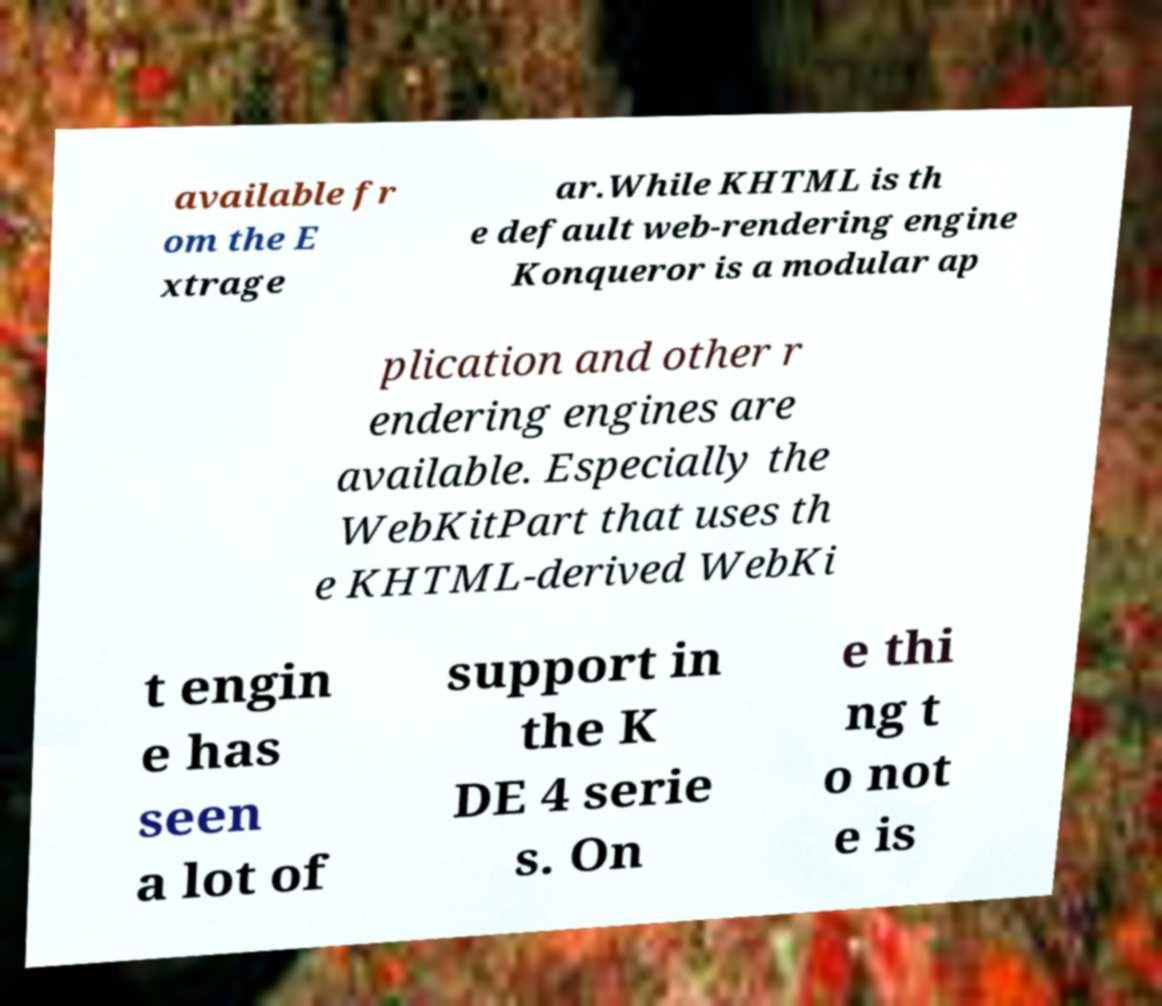Can you read and provide the text displayed in the image?This photo seems to have some interesting text. Can you extract and type it out for me? available fr om the E xtrage ar.While KHTML is th e default web-rendering engine Konqueror is a modular ap plication and other r endering engines are available. Especially the WebKitPart that uses th e KHTML-derived WebKi t engin e has seen a lot of support in the K DE 4 serie s. On e thi ng t o not e is 